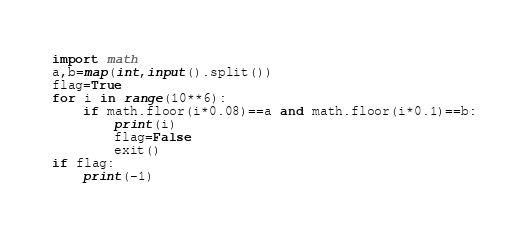<code> <loc_0><loc_0><loc_500><loc_500><_Python_>import math
a,b=map(int,input().split())
flag=True
for i in range(10**6):
    if math.floor(i*0.08)==a and math.floor(i*0.1)==b:
        print(i)
        flag=False
        exit()
if flag:
    print(-1)</code> 